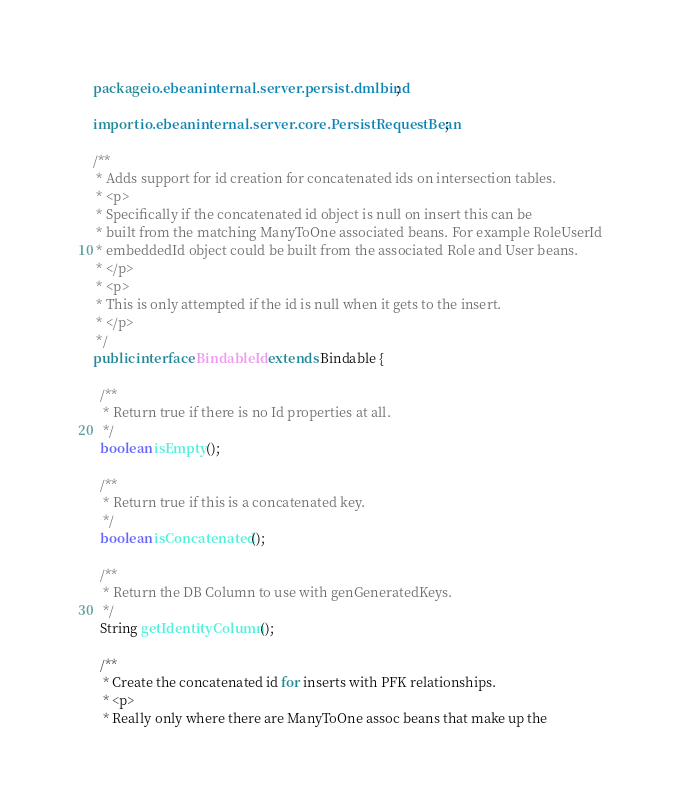Convert code to text. <code><loc_0><loc_0><loc_500><loc_500><_Java_>package io.ebeaninternal.server.persist.dmlbind;

import io.ebeaninternal.server.core.PersistRequestBean;

/**
 * Adds support for id creation for concatenated ids on intersection tables.
 * <p>
 * Specifically if the concatenated id object is null on insert this can be
 * built from the matching ManyToOne associated beans. For example RoleUserId
 * embeddedId object could be built from the associated Role and User beans.
 * </p>
 * <p>
 * This is only attempted if the id is null when it gets to the insert.
 * </p>
 */
public interface BindableId extends Bindable {

  /**
   * Return true if there is no Id properties at all.
   */
  boolean isEmpty();

  /**
   * Return true if this is a concatenated key.
   */
  boolean isConcatenated();

  /**
   * Return the DB Column to use with genGeneratedKeys.
   */
  String getIdentityColumn();

  /**
   * Create the concatenated id for inserts with PFK relationships.
   * <p>
   * Really only where there are ManyToOne assoc beans that make up the</code> 